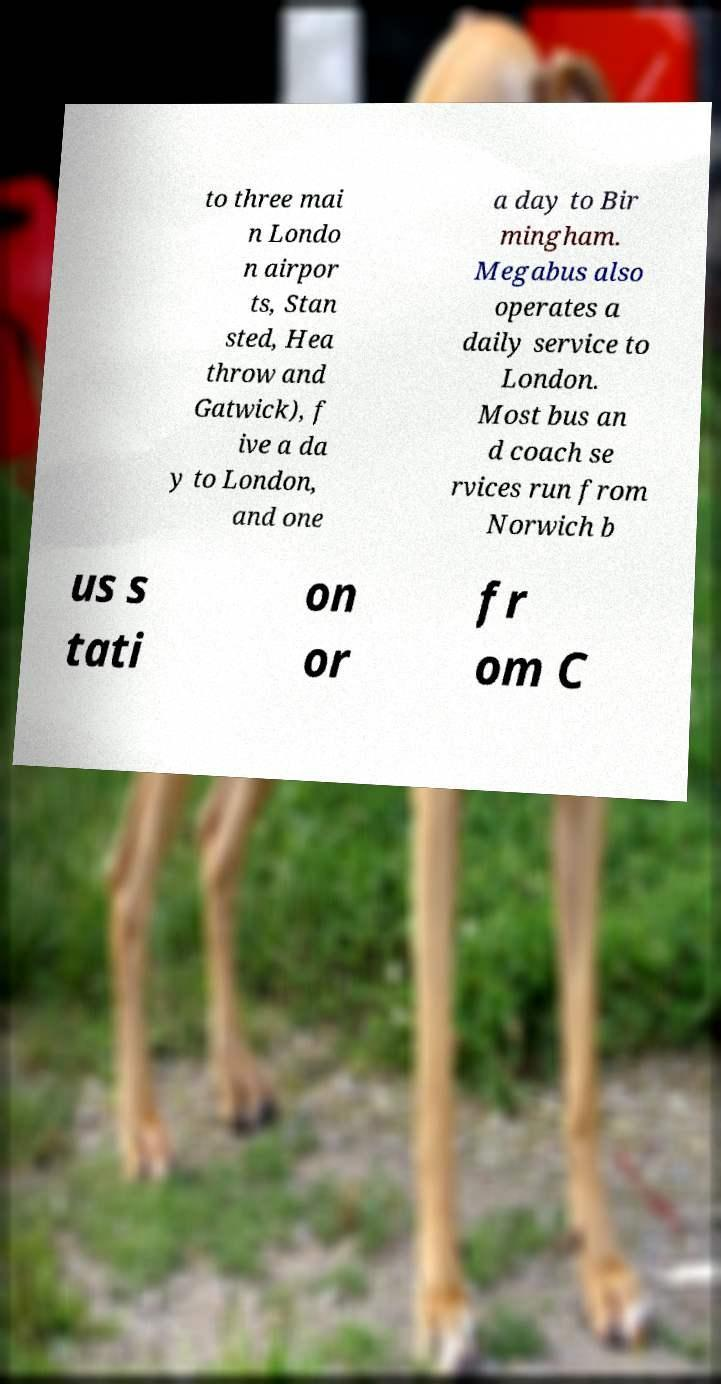Please read and relay the text visible in this image. What does it say? to three mai n Londo n airpor ts, Stan sted, Hea throw and Gatwick), f ive a da y to London, and one a day to Bir mingham. Megabus also operates a daily service to London. Most bus an d coach se rvices run from Norwich b us s tati on or fr om C 